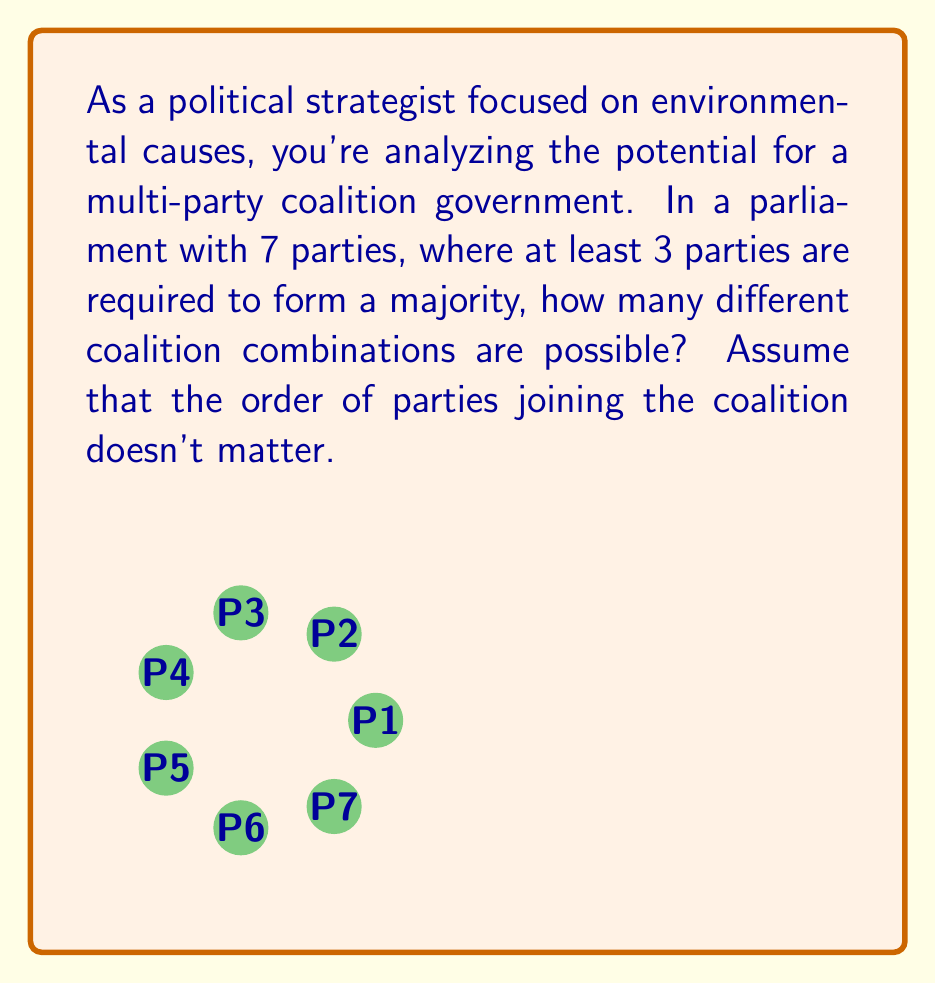Give your solution to this math problem. To solve this problem, we need to use the concept of combinations. We're looking for the sum of all possible combinations of 3, 4, 5, 6, and 7 parties from a total of 7 parties.

1) For coalitions of 3 parties: $\binom{7}{3}$
2) For coalitions of 4 parties: $\binom{7}{4}$
3) For coalitions of 5 parties: $\binom{7}{5}$
4) For coalitions of 6 parties: $\binom{7}{6}$
5) For coalitions of 7 parties: $\binom{7}{7}$

The total number of possible coalitions is the sum of these:

$$\binom{7}{3} + \binom{7}{4} + \binom{7}{5} + \binom{7}{6} + \binom{7}{7}$$

Let's calculate each term:

1) $\binom{7}{3} = \frac{7!}{3!(7-3)!} = \frac{7!}{3!4!} = 35$
2) $\binom{7}{4} = \frac{7!}{4!(7-4)!} = \frac{7!}{4!3!} = 35$
3) $\binom{7}{5} = \frac{7!}{5!(7-5)!} = \frac{7!}{5!2!} = 21$
4) $\binom{7}{6} = \frac{7!}{6!(7-6)!} = \frac{7!}{6!1!} = 7$
5) $\binom{7}{7} = \frac{7!}{7!(7-7)!} = \frac{7!}{7!0!} = 1$

Now, we sum these values:

$$35 + 35 + 21 + 7 + 1 = 99$$

Therefore, there are 99 possible coalition combinations.
Answer: 99 